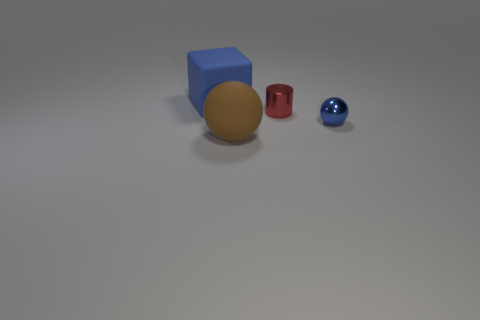How many objects are either tiny blue metallic balls or brown things?
Provide a succinct answer. 2. The large block has what color?
Your answer should be compact. Blue. How many other things are the same color as the block?
Your response must be concise. 1. Are there any blue cubes right of the small red cylinder?
Provide a short and direct response. No. There is a small thing that is behind the blue object in front of the large object that is behind the big brown thing; what is its color?
Keep it short and to the point. Red. What number of things are behind the brown matte object and in front of the red thing?
Give a very brief answer. 1. What number of cubes are either big yellow things or blue shiny things?
Ensure brevity in your answer.  0. Are any big brown objects visible?
Provide a short and direct response. Yes. How many other objects are there of the same material as the brown ball?
Provide a succinct answer. 1. There is a blue ball that is the same size as the red shiny cylinder; what is its material?
Offer a very short reply. Metal. 